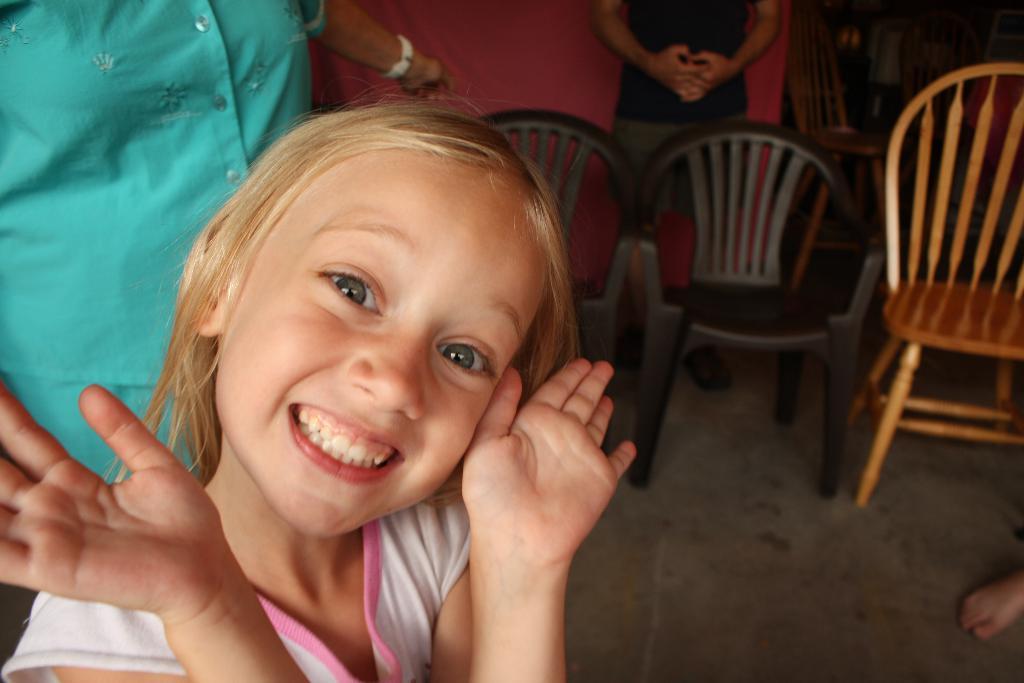Please provide a concise description of this image. In this image there is a girl smiling and the back ground there are group of people , chairs. 